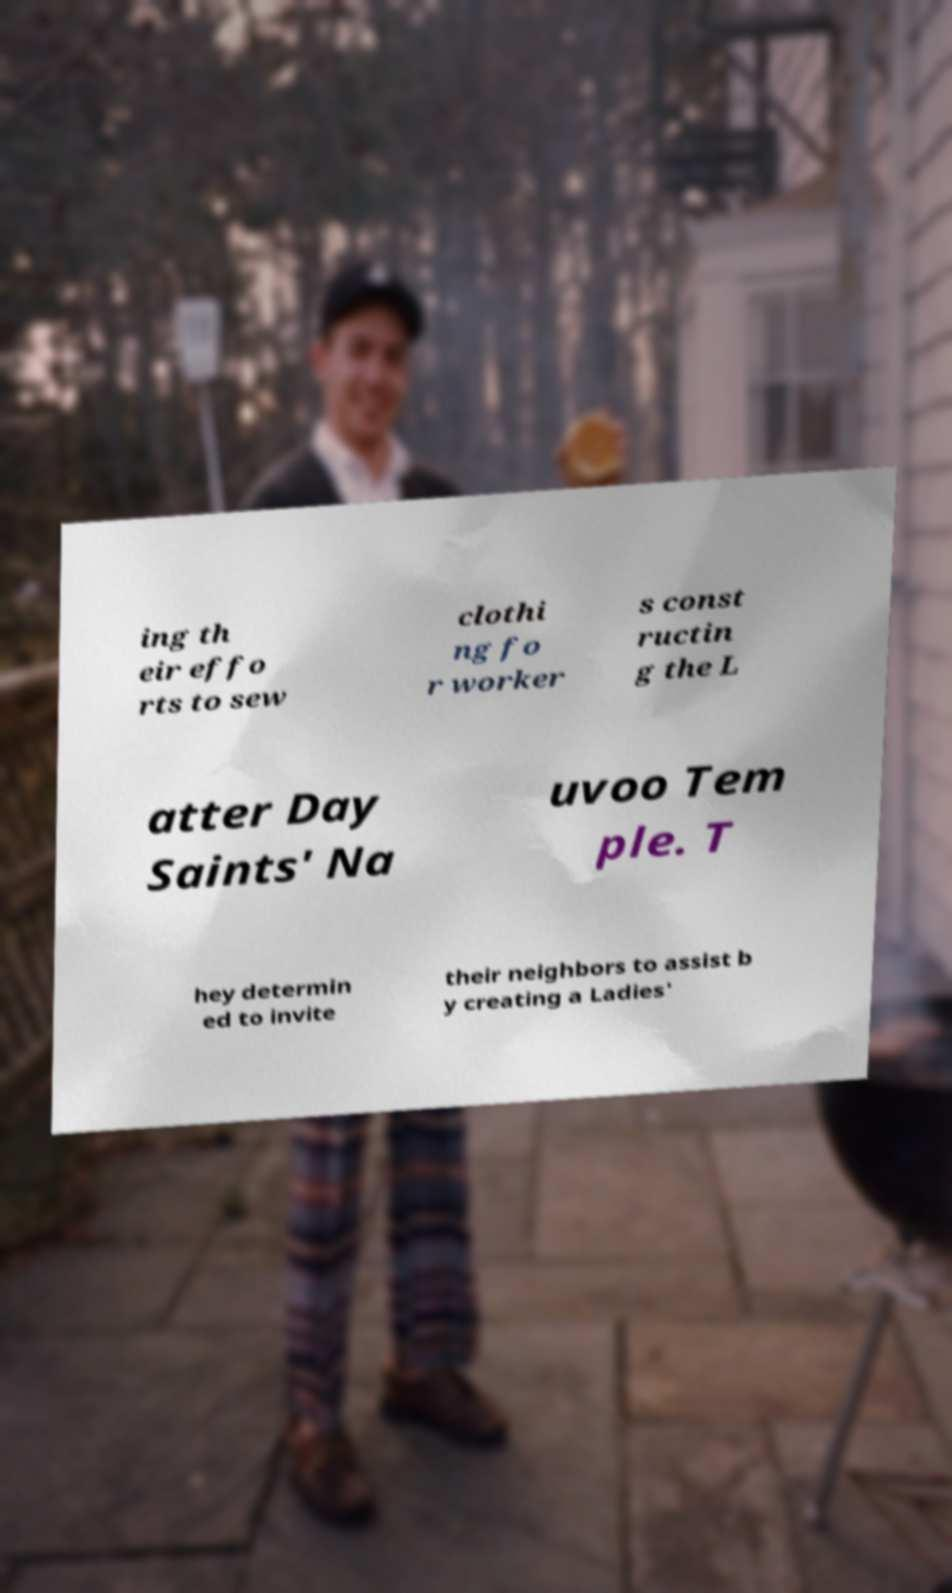Please read and relay the text visible in this image. What does it say? ing th eir effo rts to sew clothi ng fo r worker s const ructin g the L atter Day Saints' Na uvoo Tem ple. T hey determin ed to invite their neighbors to assist b y creating a Ladies' 